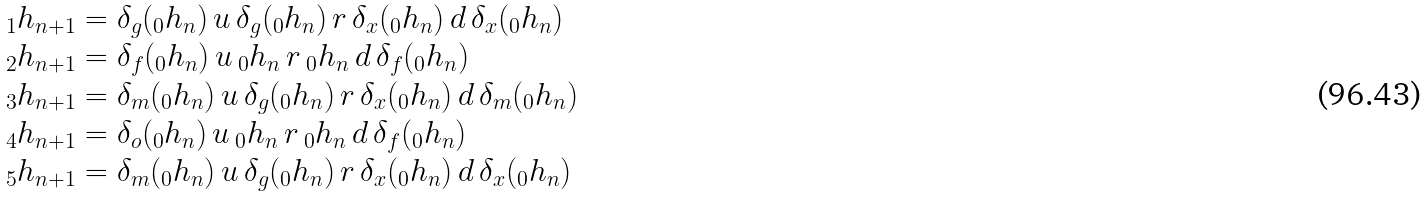Convert formula to latex. <formula><loc_0><loc_0><loc_500><loc_500>\begin{array} { l } _ { 1 } h _ { n + 1 } = \delta _ { g } ( _ { 0 } h _ { n } ) \, u \, \delta _ { g } ( _ { 0 } h _ { n } ) \, r \, \delta _ { x } ( _ { 0 } h _ { n } ) \, d \, \delta _ { x } ( _ { 0 } h _ { n } ) \\ _ { 2 } h _ { n + 1 } = \delta _ { f } ( _ { 0 } h _ { n } ) \, u \, _ { 0 } h _ { n } \, r \, _ { 0 } h _ { n } \, d \, \delta _ { f } ( _ { 0 } h _ { n } ) \\ _ { 3 } h _ { n + 1 } = \delta _ { m } ( _ { 0 } h _ { n } ) \, u \, \delta _ { g } ( _ { 0 } h _ { n } ) \, r \, \delta _ { x } ( _ { 0 } h _ { n } ) \, d \, \delta _ { m } ( _ { 0 } h _ { n } ) \\ _ { 4 } h _ { n + 1 } = \delta _ { o } ( _ { 0 } h _ { n } ) \, u \, _ { 0 } h _ { n } \, r \, _ { 0 } h _ { n } \, d \, \delta _ { f } ( _ { 0 } h _ { n } ) \\ _ { 5 } h _ { n + 1 } = \delta _ { m } ( _ { 0 } h _ { n } ) \, u \, \delta _ { g } ( _ { 0 } h _ { n } ) \, r \, \delta _ { x } ( _ { 0 } h _ { n } ) \, d \, \delta _ { x } ( _ { 0 } h _ { n } ) \end{array}</formula> 